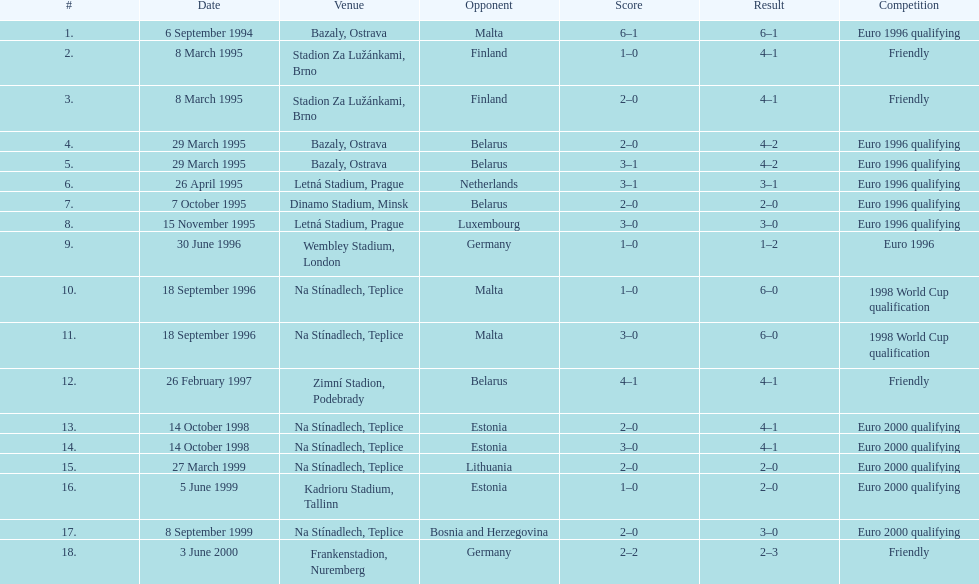Name the competitors taking part in the amicable competition. Finland, Belarus, Germany. 